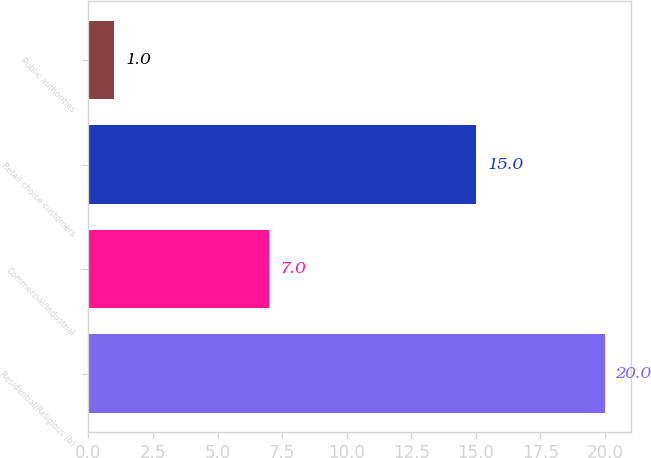Convert chart. <chart><loc_0><loc_0><loc_500><loc_500><bar_chart><fcel>Residential/Religious (b)<fcel>Commercial/Industrial<fcel>Retail choice customers<fcel>Public authorities<nl><fcel>20<fcel>7<fcel>15<fcel>1<nl></chart> 